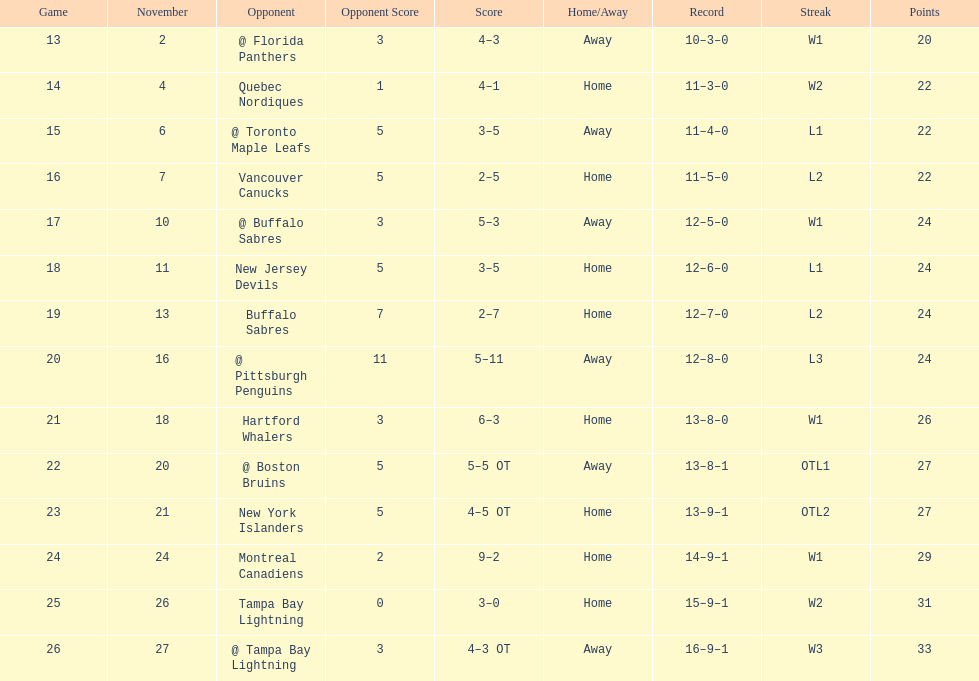Can you parse all the data within this table? {'header': ['Game', 'November', 'Opponent', 'Opponent Score', 'Score', 'Home/Away', 'Record', 'Streak', 'Points'], 'rows': [['13', '2', '@ Florida Panthers', '3', '4–3', 'Away', '10–3–0', 'W1', '20'], ['14', '4', 'Quebec Nordiques', '1', '4–1', 'Home', '11–3–0', 'W2', '22'], ['15', '6', '@ Toronto Maple Leafs', '5', '3–5', 'Away', '11–4–0', 'L1', '22'], ['16', '7', 'Vancouver Canucks', '5', '2–5', 'Home', '11–5–0', 'L2', '22'], ['17', '10', '@ Buffalo Sabres', '3', '5–3', 'Away', '12–5–0', 'W1', '24'], ['18', '11', 'New Jersey Devils', '5', '3–5', 'Home', '12–6–0', 'L1', '24'], ['19', '13', 'Buffalo Sabres', '7', '2–7', 'Home', '12–7–0', 'L2', '24'], ['20', '16', '@ Pittsburgh Penguins', '11', '5–11', 'Away', '12–8–0', 'L3', '24'], ['21', '18', 'Hartford Whalers', '3', '6–3', 'Home', '13–8–0', 'W1', '26'], ['22', '20', '@ Boston Bruins', '5', '5–5 OT', 'Away', '13–8–1', 'OTL1', '27'], ['23', '21', 'New York Islanders', '5', '4–5 OT', 'Home', '13–9–1', 'OTL2', '27'], ['24', '24', 'Montreal Canadiens', '2', '9–2', 'Home', '14–9–1', 'W1', '29'], ['25', '26', 'Tampa Bay Lightning', '0', '3–0', 'Home', '15–9–1', 'W2', '31'], ['26', '27', '@ Tampa Bay Lightning', '3', '4–3 OT', 'Away', '16–9–1', 'W3', '33']]} What was the overall sum of penalty minutes dave brown accumulated during the 1993-1994 flyers season? 137. 